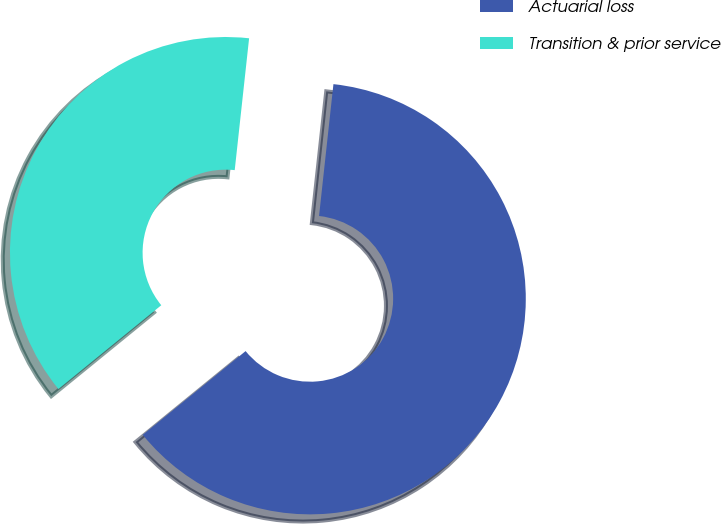<chart> <loc_0><loc_0><loc_500><loc_500><pie_chart><fcel>Actuarial loss<fcel>Transition & prior service<nl><fcel>62.39%<fcel>37.61%<nl></chart> 